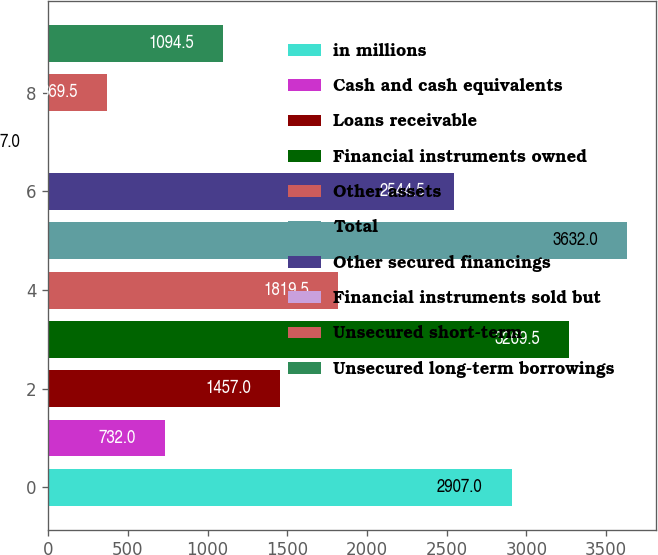<chart> <loc_0><loc_0><loc_500><loc_500><bar_chart><fcel>in millions<fcel>Cash and cash equivalents<fcel>Loans receivable<fcel>Financial instruments owned<fcel>Other assets<fcel>Total<fcel>Other secured financings<fcel>Financial instruments sold but<fcel>Unsecured short-term<fcel>Unsecured long-term borrowings<nl><fcel>2907<fcel>732<fcel>1457<fcel>3269.5<fcel>1819.5<fcel>3632<fcel>2544.5<fcel>7<fcel>369.5<fcel>1094.5<nl></chart> 